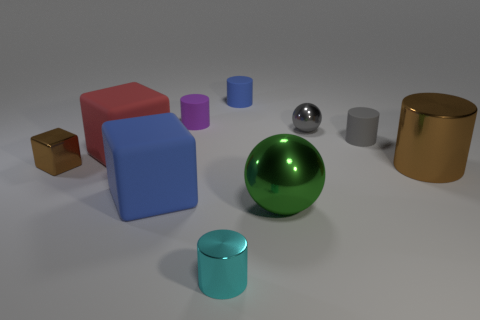Subtract all large metal cylinders. How many cylinders are left? 4 Subtract all purple cylinders. How many cylinders are left? 4 Subtract 2 cubes. How many cubes are left? 1 Subtract all cubes. How many objects are left? 7 Add 3 red cubes. How many red cubes exist? 4 Subtract 0 brown balls. How many objects are left? 10 Subtract all brown cylinders. Subtract all cyan blocks. How many cylinders are left? 4 Subtract all purple balls. How many red cubes are left? 1 Subtract all small rubber cylinders. Subtract all metallic balls. How many objects are left? 5 Add 6 rubber cylinders. How many rubber cylinders are left? 9 